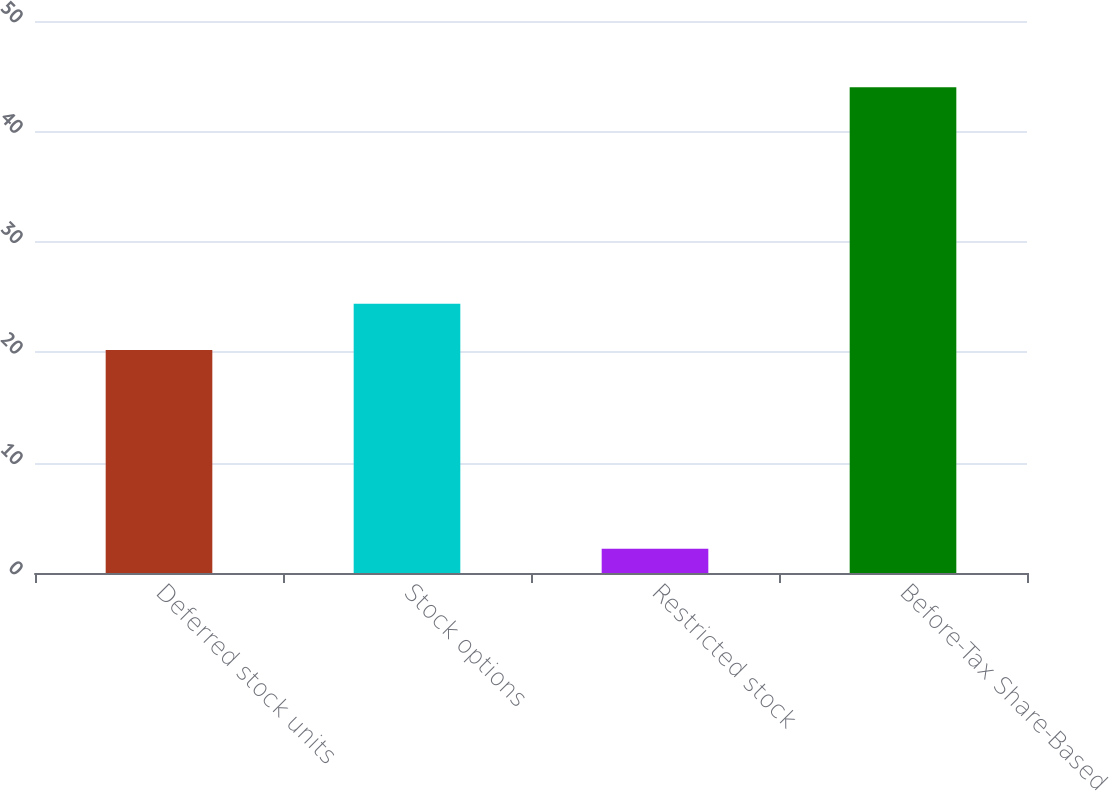Convert chart to OTSL. <chart><loc_0><loc_0><loc_500><loc_500><bar_chart><fcel>Deferred stock units<fcel>Stock options<fcel>Restricted stock<fcel>Before-Tax Share-Based<nl><fcel>20.2<fcel>24.38<fcel>2.2<fcel>44<nl></chart> 